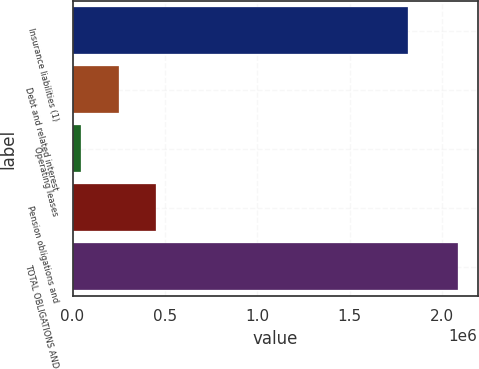Convert chart. <chart><loc_0><loc_0><loc_500><loc_500><bar_chart><fcel>Insurance liabilities (1)<fcel>Debt and related interest<fcel>Operating leases<fcel>Pension obligations and<fcel>TOTAL OBLIGATIONS AND<nl><fcel>1.81268e+06<fcel>248608<fcel>44422<fcel>452794<fcel>2.08628e+06<nl></chart> 